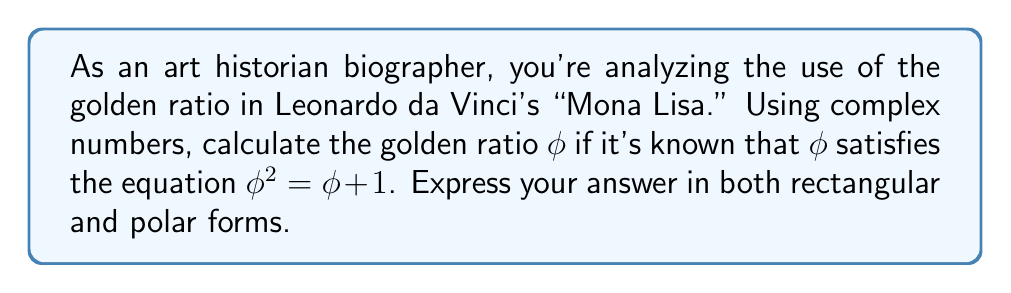Could you help me with this problem? To solve this problem, we'll follow these steps:

1) The golden ratio φ satisfies the equation $φ^2 = φ + 1$

2) Rearrange the equation to standard form:
   $φ^2 - φ - 1 = 0$

3) This is a quadratic equation. We can solve it using the quadratic formula:
   $φ = \frac{-b \pm \sqrt{b^2 - 4ac}}{2a}$

   Where $a=1$, $b=-1$, and $c=-1$

4) Substituting these values:
   $φ = \frac{1 \pm \sqrt{1^2 - 4(1)(-1)}}{2(1)} = \frac{1 \pm \sqrt{5}}{2}$

5) The positive solution is the golden ratio:
   $φ = \frac{1 + \sqrt{5}}{2}$

6) To express this in rectangular form of a complex number:
   $φ = \frac{1}{2} + i\frac{\sqrt{5}}{2}$

7) To convert to polar form, we need to calculate the modulus (r) and argument (θ):
   
   $r = \sqrt{(\frac{1}{2})^2 + (\frac{\sqrt{5}}{2})^2} = \sqrt{\frac{1}{4} + \frac{5}{4}} = \sqrt{\frac{3}{2}} = \frac{\sqrt{6}}{2}$

   $θ = \arctan(\frac{\sqrt{5}}{1}) \approx 1.1868$ radians or $68.0175°$

8) Therefore, in polar form:
   $φ = \frac{\sqrt{6}}{2}(\cos(1.1868) + i\sin(1.1868))$

   Or using Euler's formula:
   $φ = \frac{\sqrt{6}}{2}e^{1.1868i}$
Answer: Rectangular form: $φ = \frac{1}{2} + i\frac{\sqrt{5}}{2}$
Polar form: $φ = \frac{\sqrt{6}}{2}e^{1.1868i}$ or $φ = \frac{\sqrt{6}}{2}(\cos(1.1868) + i\sin(1.1868))$ 